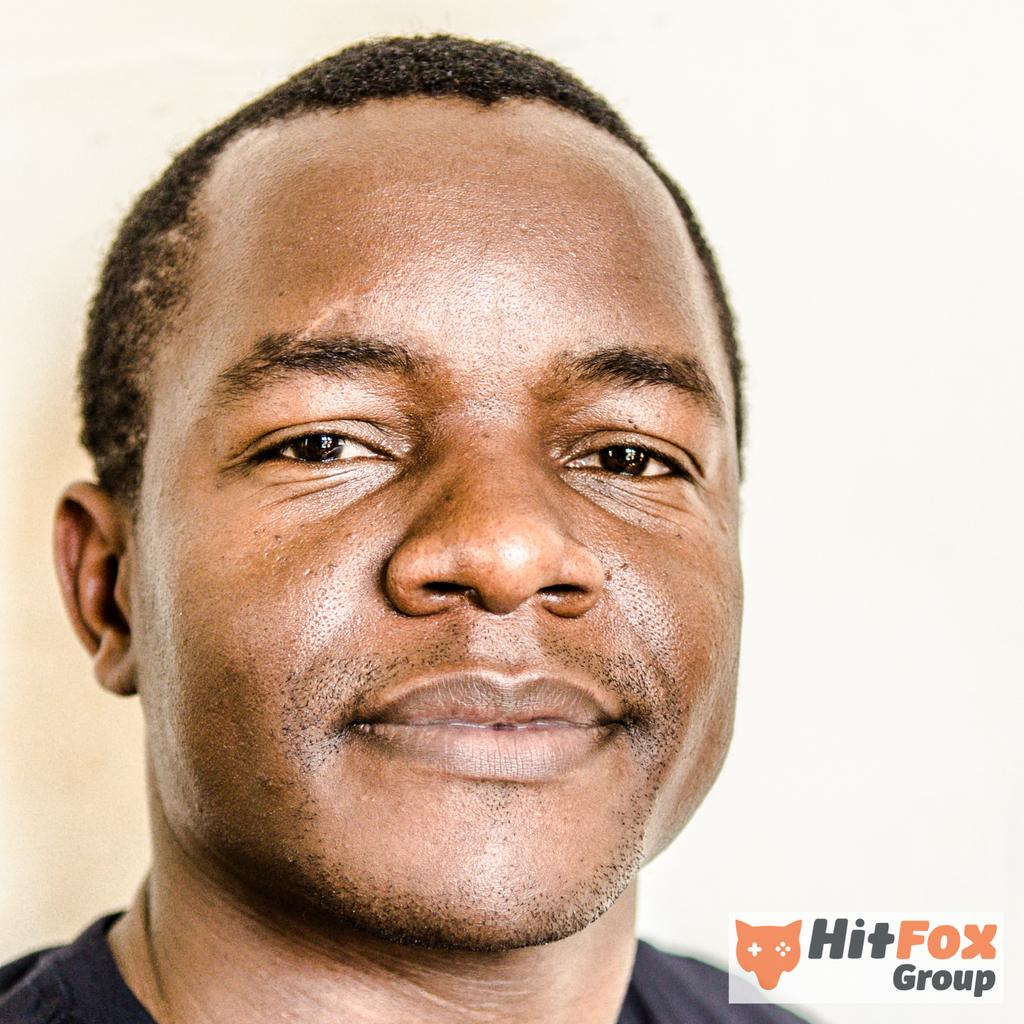Who is present in the image? There is a man in the image. What is the man wearing? The man is wearing a black shirt. What color is the background of the image? The background of the image is white. What type of flowers can be seen in the man's grip in the image? There are no flowers present in the image, and the man is not holding anything in his grip. 